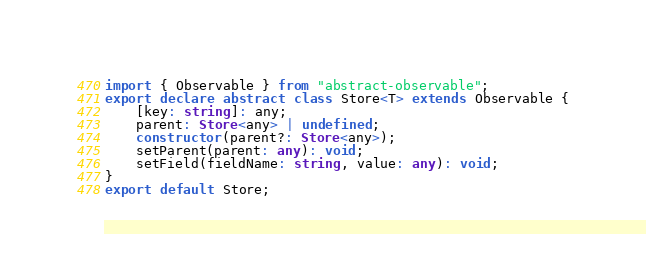<code> <loc_0><loc_0><loc_500><loc_500><_TypeScript_>import { Observable } from "abstract-observable";
export declare abstract class Store<T> extends Observable {
    [key: string]: any;
    parent: Store<any> | undefined;
    constructor(parent?: Store<any>);
    setParent(parent: any): void;
    setField(fieldName: string, value: any): void;
}
export default Store;
</code> 